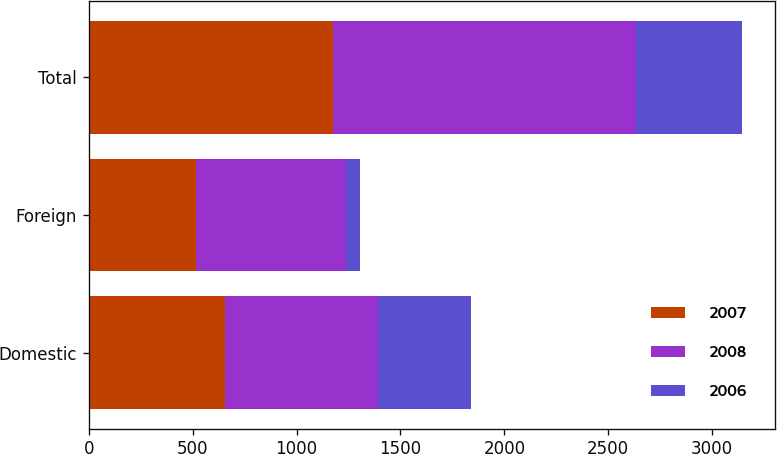Convert chart. <chart><loc_0><loc_0><loc_500><loc_500><stacked_bar_chart><ecel><fcel>Domestic<fcel>Foreign<fcel>Total<nl><fcel>2007<fcel>657<fcel>517<fcel>1174<nl><fcel>2008<fcel>736<fcel>723<fcel>1459<nl><fcel>2006<fcel>448<fcel>64<fcel>512<nl></chart> 